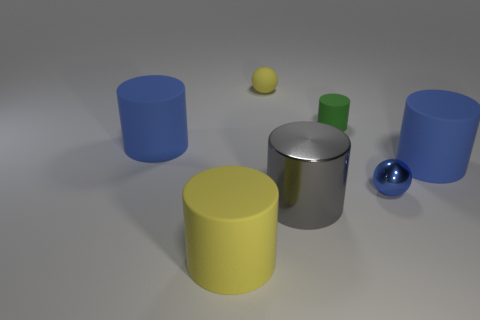Add 1 balls. How many objects exist? 8 Subtract all big blue cylinders. How many cylinders are left? 3 Subtract 0 purple blocks. How many objects are left? 7 Subtract all spheres. How many objects are left? 5 Subtract 1 balls. How many balls are left? 1 Subtract all blue cylinders. Subtract all purple blocks. How many cylinders are left? 3 Subtract all purple spheres. How many green cylinders are left? 1 Subtract all large gray shiny objects. Subtract all red cylinders. How many objects are left? 6 Add 2 yellow cylinders. How many yellow cylinders are left? 3 Add 7 shiny cylinders. How many shiny cylinders exist? 8 